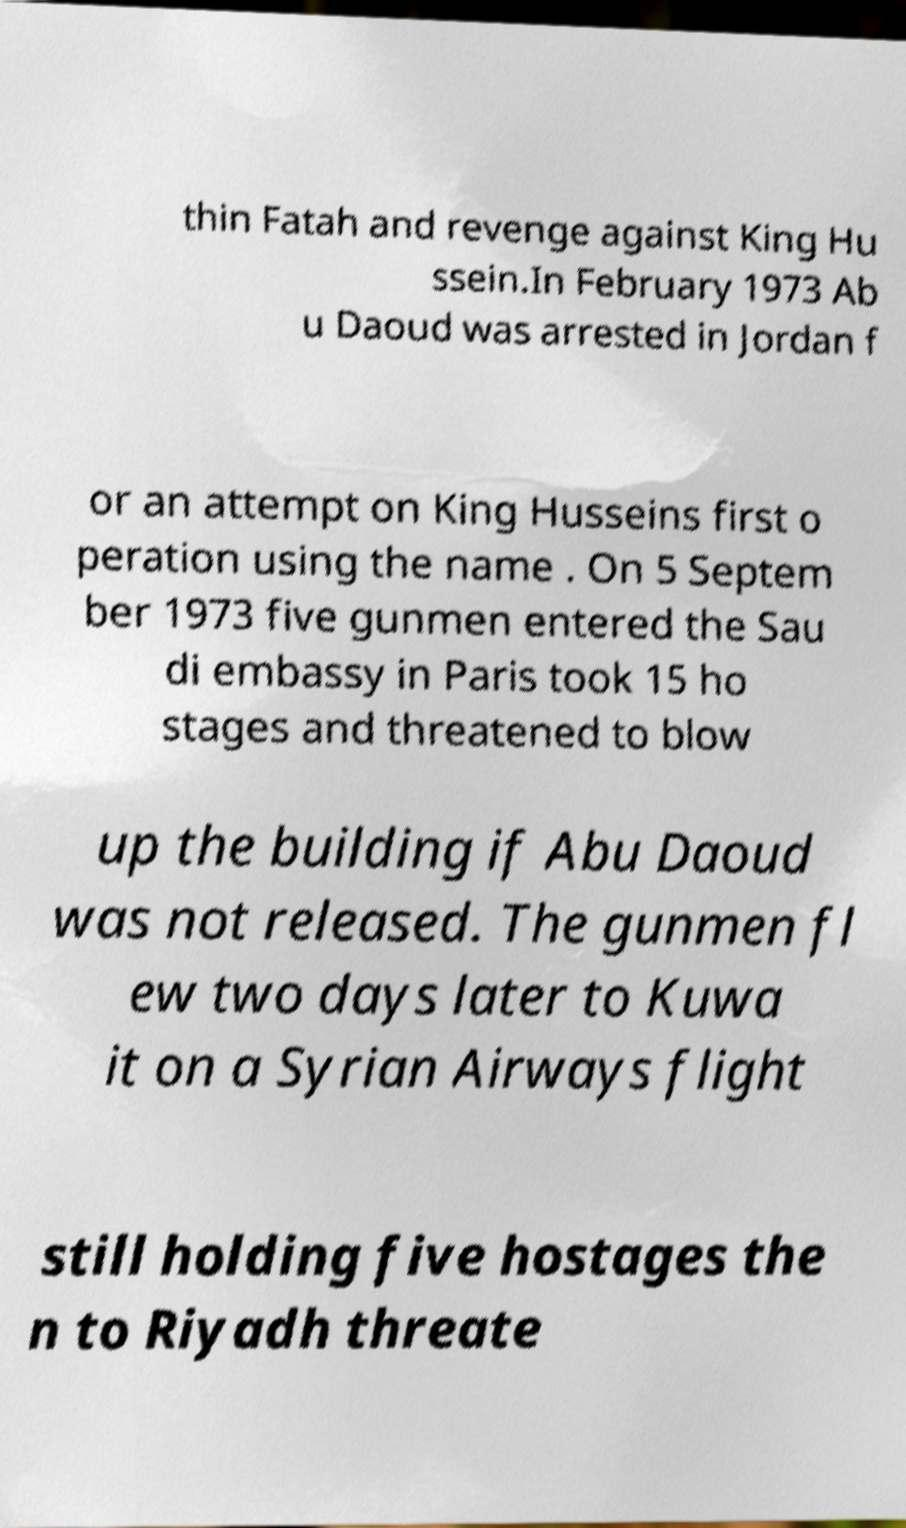What messages or text are displayed in this image? I need them in a readable, typed format. thin Fatah and revenge against King Hu ssein.In February 1973 Ab u Daoud was arrested in Jordan f or an attempt on King Husseins first o peration using the name . On 5 Septem ber 1973 five gunmen entered the Sau di embassy in Paris took 15 ho stages and threatened to blow up the building if Abu Daoud was not released. The gunmen fl ew two days later to Kuwa it on a Syrian Airways flight still holding five hostages the n to Riyadh threate 